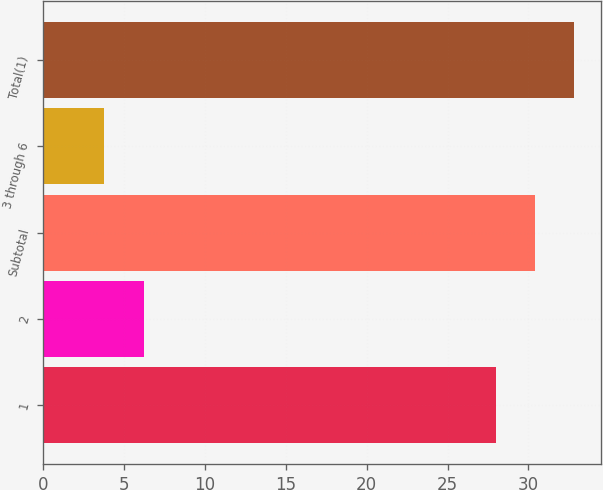<chart> <loc_0><loc_0><loc_500><loc_500><bar_chart><fcel>1<fcel>2<fcel>Subtotal<fcel>3 through 6<fcel>Total(1)<nl><fcel>28<fcel>6.2<fcel>30.42<fcel>3.78<fcel>32.84<nl></chart> 